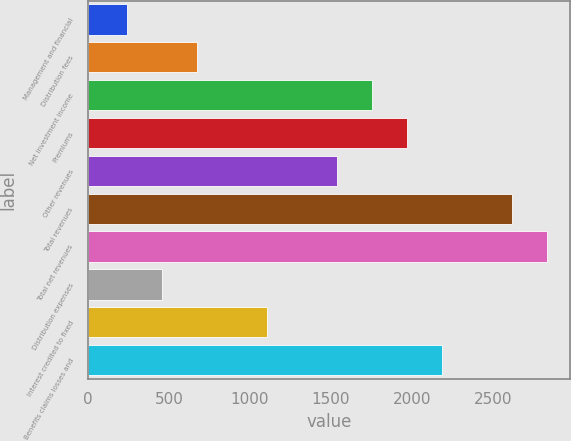Convert chart to OTSL. <chart><loc_0><loc_0><loc_500><loc_500><bar_chart><fcel>Management and financial<fcel>Distribution fees<fcel>Net investment income<fcel>Premiums<fcel>Other revenues<fcel>Total revenues<fcel>Total net revenues<fcel>Distribution expenses<fcel>Interest credited to fixed<fcel>Benefits claims losses and<nl><fcel>241.1<fcel>673.3<fcel>1753.8<fcel>1969.9<fcel>1537.7<fcel>2618.2<fcel>2834.3<fcel>457.2<fcel>1105.5<fcel>2186<nl></chart> 